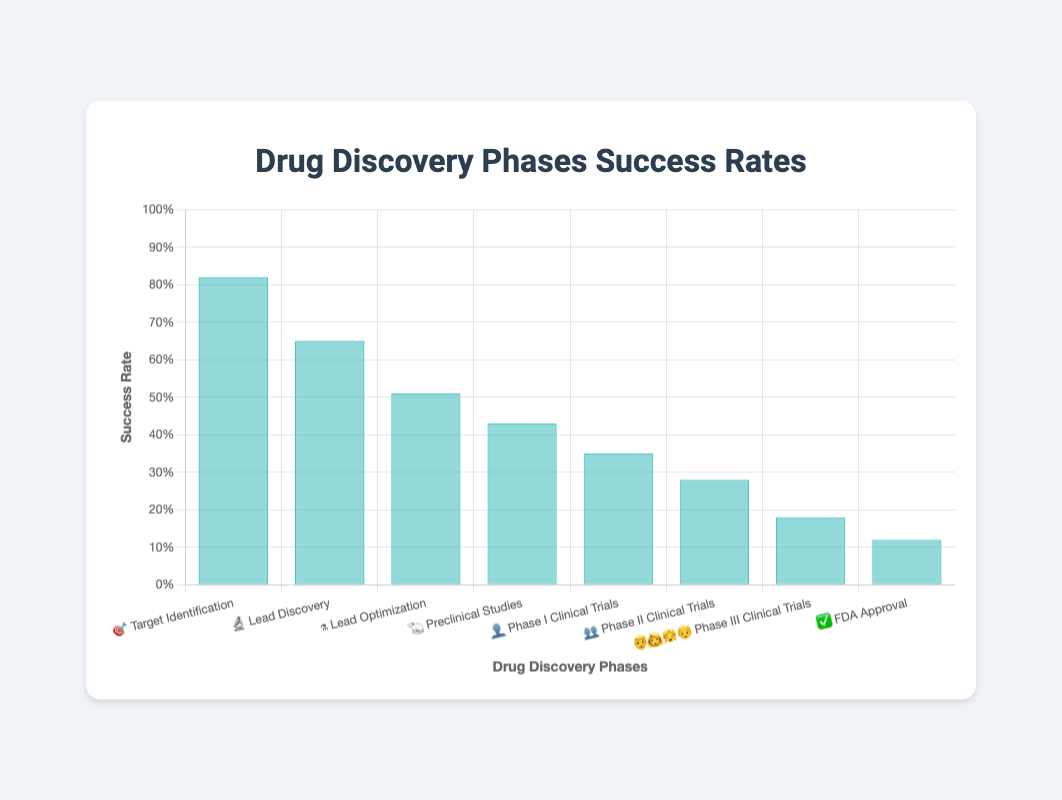What's the success rate of the Lead Discovery phase? The "Lead Discovery" phase is represented by the microscope emoji 🔬. According to the chart, its success rate is indicated by the bar's height on the y-axis. It reaches the 0.65 mark.
Answer: 0.65 Which phase has the lowest success rate? To determine this, look at the heights of all the bars and see which one is the shortest. The "FDA Approval" phase, represented by the check mark emoji ✅, has the lowest success rate, shown by the bar that goes up to 0.12.
Answer: FDA Approval How many phases have a success rate higher than 50%? To find this, count the number of phases with bars that are higher than the 0.5 mark on the y-axis. The phases are "Target Identification" 🎯 and "Lead Discovery" 🔬 with success rates of 0.82 and 0.65 respectively, making it 2.
Answer: 2 What is the difference in success rates between Phase I Clinical Trials and FDA Approval? Look at the y-axis values for "Phase I Clinical Trials" 👤 and "FDA Approval" ✅. The success rates are 0.35 and 0.12 respectively. Subtract the smaller from the larger: 0.35 - 0.12 equals 0.23.
Answer: 0.23 Which phase has a higher success rate, Preclinical Studies or Lead Optimization? Compare the heights of the bars for "Preclinical Studies" 🐁 and "Lead Optimization" ⚗️ phases. "Lead Optimization" has a success rate of 0.51 while "Preclinical Studies" has 0.43. Therefore, "Lead Optimization" has a higher success rate.
Answer: Lead Optimization What's the combined success rate of "Phase I Clinical Trials" and "Phase II Clinical Trials"? Add the success rates of "Phase I Clinical Trials" 👤 (0.35) and "Phase II Clinical Trials" 👥 (0.28): 0.35 + 0.28 equals 0.63.
Answer: 0.63 Which phase has the emoji representing a family? The family emoji is used to represent the "Phase III Clinical Trials" phase.
Answer: Phase III Clinical Trials Is the success rate of Target Identification closer to 1 or to 0? The success rate of "Target Identification" 🎯 is 0.82. Between 0 and 1, 0.82 is closer to 1.
Answer: 1 Compare the success rates of the Phase II and Phase III Clinical Trials phases. Which is greater? The bars representing "Phase II Clinical Trials" 👥 and "Phase III Clinical Trials" 👨‍👩‍👧‍👦 phases have heights equivalent to 0.28 and 0.18 respectively. Therefore, the success rate of "Phase II Clinical Trials" is greater.
Answer: Phase II Clinical Trials 